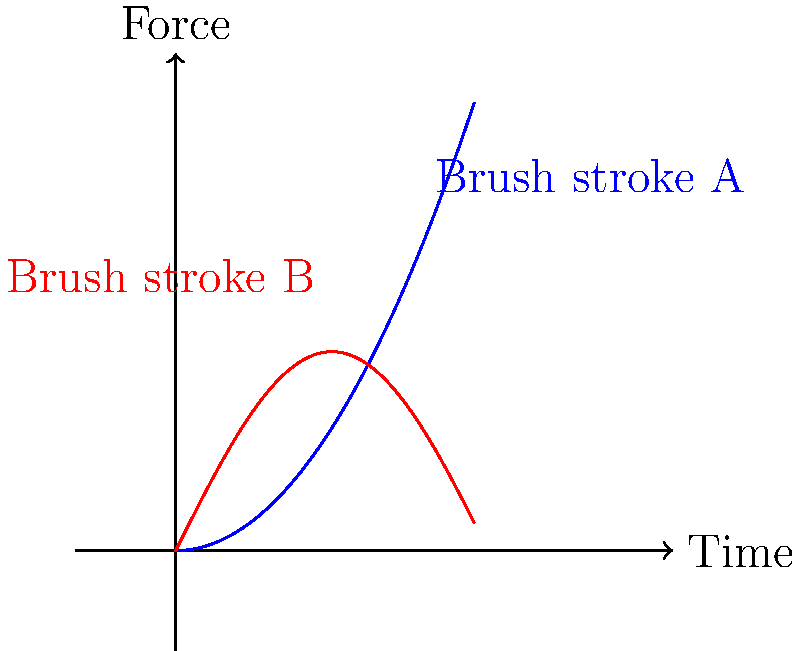As an artist, you're studying the biomechanics of brush strokes. The graph shows the force applied over time for two different brush strokes, A and B. Which brush stroke technique is likely to produce more consistent line thickness, and why? To determine which brush stroke technique is likely to produce more consistent line thickness, we need to analyze the force-time graphs for both strokes:

1. Brush stroke A (blue curve):
   - The force increases quadratically over time (parabolic shape).
   - This indicates a continuously increasing force application.

2. Brush stroke B (red curve):
   - The force follows a sinusoidal pattern.
   - This indicates a cyclical variation in force application.

3. Consistency in line thickness:
   - Line thickness is generally proportional to the force applied to the brush.
   - A more consistent force will result in a more consistent line thickness.

4. Comparing the two strokes:
   - Stroke A shows a continuously changing force, which would likely result in a varying line thickness.
   - Stroke B shows a repeating pattern of force, with more consistent maximum and minimum values.

5. Biomechanical interpretation:
   - Stroke A might represent a single, long brush stroke with increasing pressure.
   - Stroke B could represent a series of shorter, repeated brush strokes or a technique involving rhythmic arm motion.

6. Conclusion:
   - Brush stroke B is more likely to produce consistent line thickness due to its repeating force pattern.
   - The cyclical nature of stroke B allows for more control and regularity in force application.
Answer: Brush stroke B, due to its cyclical force pattern. 